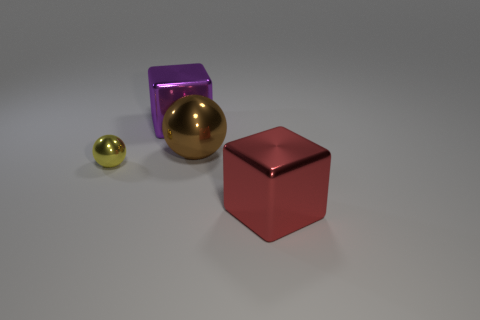Add 4 big red objects. How many objects exist? 8 Subtract all yellow balls. How many balls are left? 1 Subtract 1 spheres. How many spheres are left? 1 Subtract all brown spheres. How many red cubes are left? 1 Subtract all big purple blocks. Subtract all large metal cubes. How many objects are left? 1 Add 1 tiny yellow things. How many tiny yellow things are left? 2 Add 4 big brown balls. How many big brown balls exist? 5 Subtract 0 brown cubes. How many objects are left? 4 Subtract all purple spheres. Subtract all cyan cylinders. How many spheres are left? 2 